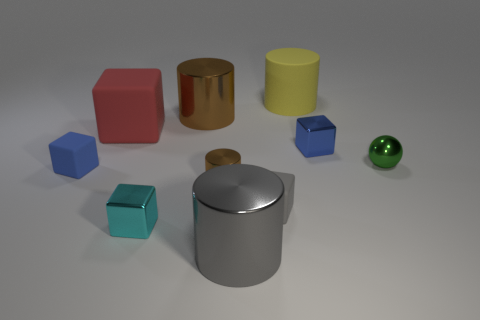Subtract all cyan spheres. Subtract all cyan cubes. How many spheres are left? 1 Subtract all balls. How many objects are left? 9 Subtract 0 yellow cubes. How many objects are left? 10 Subtract all big red shiny cubes. Subtract all red things. How many objects are left? 9 Add 1 red rubber blocks. How many red rubber blocks are left? 2 Add 6 small gray rubber cubes. How many small gray rubber cubes exist? 7 